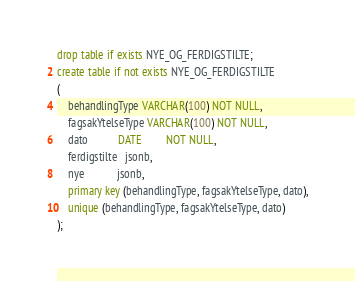Convert code to text. <code><loc_0><loc_0><loc_500><loc_500><_SQL_>drop table if exists NYE_OG_FERDIGSTILTE;
create table if not exists NYE_OG_FERDIGSTILTE
(
    behandlingType VARCHAR(100) NOT NULL,
    fagsakYtelseType VARCHAR(100) NOT NULL,
    dato           DATE         NOT NULL,
    ferdigstilte   jsonb,
    nye            jsonb,
    primary key (behandlingType, fagsakYtelseType, dato),
    unique (behandlingType, fagsakYtelseType, dato)
);
</code> 